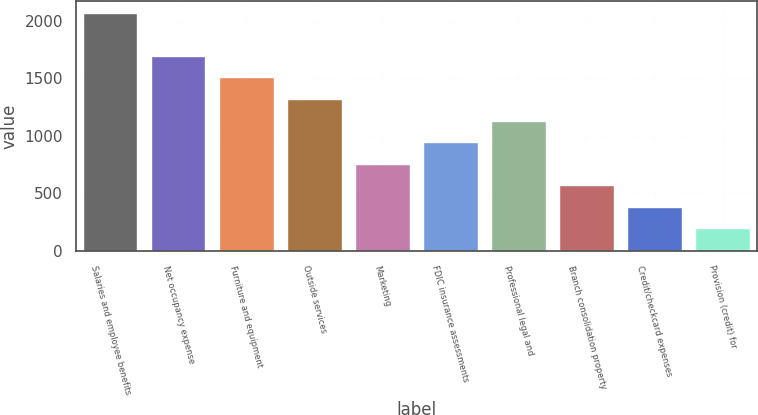Convert chart. <chart><loc_0><loc_0><loc_500><loc_500><bar_chart><fcel>Salaries and employee benefits<fcel>Net occupancy expense<fcel>Furniture and equipment<fcel>Outside services<fcel>Marketing<fcel>FDIC insurance assessments<fcel>Professional legal and<fcel>Branch consolidation property<fcel>Credit/checkcard expenses<fcel>Provision (credit) for<nl><fcel>2070.4<fcel>1695.6<fcel>1508.2<fcel>1320.8<fcel>758.6<fcel>946<fcel>1133.4<fcel>571.2<fcel>383.8<fcel>196.4<nl></chart> 